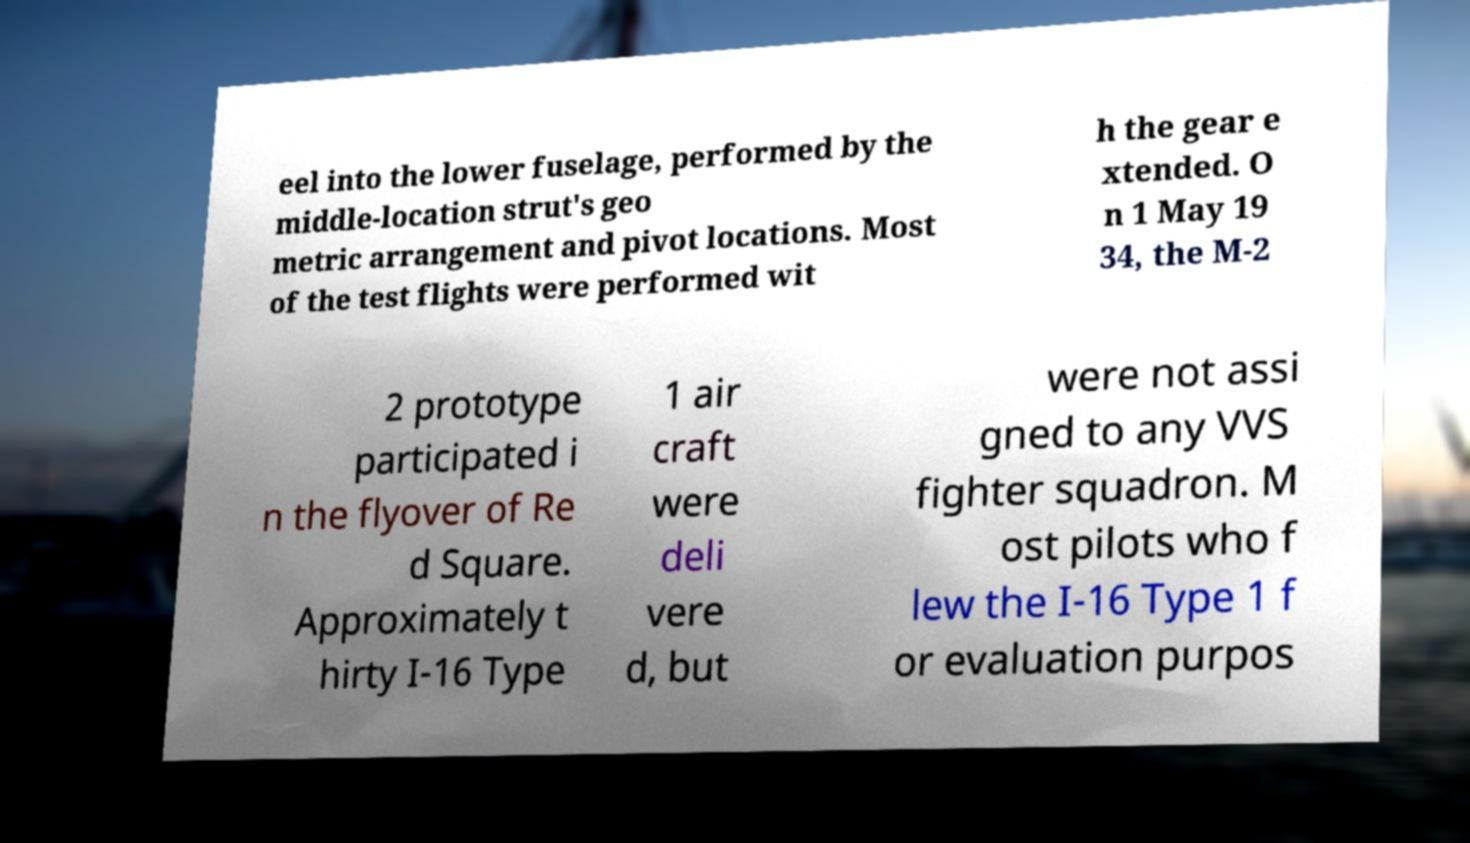There's text embedded in this image that I need extracted. Can you transcribe it verbatim? eel into the lower fuselage, performed by the middle-location strut's geo metric arrangement and pivot locations. Most of the test flights were performed wit h the gear e xtended. O n 1 May 19 34, the M-2 2 prototype participated i n the flyover of Re d Square. Approximately t hirty I-16 Type 1 air craft were deli vere d, but were not assi gned to any VVS fighter squadron. M ost pilots who f lew the I-16 Type 1 f or evaluation purpos 